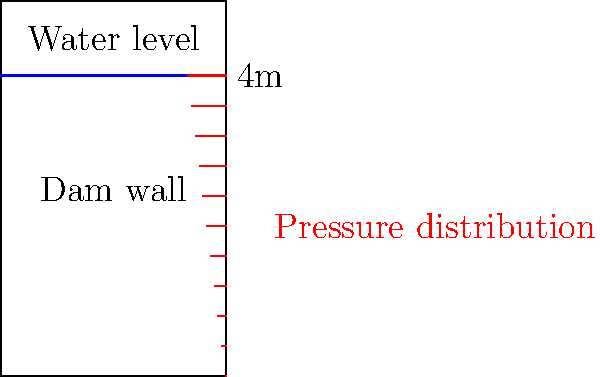A concrete dam wall has a rectangular cross-section and is 4 meters high. The water level reaches the top of the dam. Using the principles of hydrostatics, calculate the total force exerted by the water on the dam wall per meter length. Assume the density of water is 1000 kg/m³ and the acceleration due to gravity is 9.81 m/s². How would you explain this concept to your homeschooled children using everyday objects? Let's break this down step-by-step:

1) The pressure in a fluid increases linearly with depth due to the weight of the fluid above. At any depth $h$, the pressure is given by:

   $P = \rho g h$

   Where $\rho$ is the density of water and $g$ is the acceleration due to gravity.

2) The pressure at the bottom of the dam (where $h = 4$ m) is:

   $P_{max} = 1000 \text{ kg/m³} \times 9.81 \text{ m/s²} \times 4 \text{ m} = 39,240 \text{ Pa}$

3) The pressure distribution is triangular, with zero pressure at the top and maximum pressure at the bottom.

4) The average pressure is half of the maximum pressure:

   $P_{avg} = \frac{39,240 \text{ Pa}}{2} = 19,620 \text{ Pa}$

5) The total force is the average pressure multiplied by the area:

   $F = P_{avg} \times \text{Area} = 19,620 \text{ Pa} \times 4 \text{ m} \times 1 \text{ m} = 78,480 \text{ N}$

To explain this to children using everyday objects:
- Fill a tall, clear container with water and mark different levels.
- Use a small waterproof object (like a ping pong ball) attached to a string.
- Lower the ball into the water and let children feel how the force increases with depth.
- Use a flat board held vertically in a bathtub or pool to demonstrate the increasing pressure with depth.

This hands-on approach aligns with the minimal technology preference while providing a tangible understanding of water pressure.
Answer: 78,480 N (or approximately 78.5 kN) per meter length of the dam 